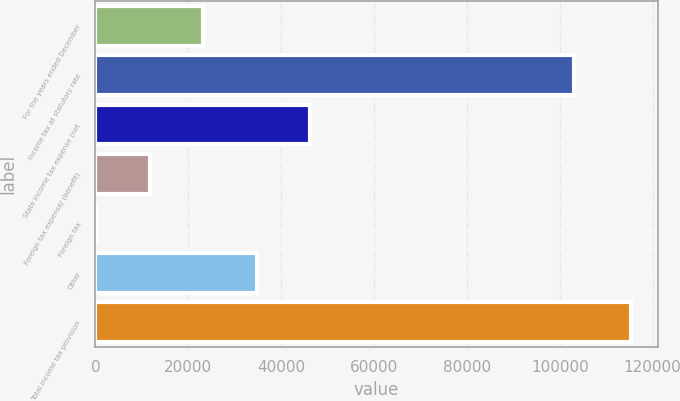Convert chart. <chart><loc_0><loc_0><loc_500><loc_500><bar_chart><fcel>For the years ended December<fcel>Income tax at statutory rate<fcel>State income tax expense (net<fcel>Foreign tax expense/ (benefit)<fcel>Foreign tax<fcel>Other<fcel>Total income tax provision<nl><fcel>23252.4<fcel>103075<fcel>46283.8<fcel>11736.7<fcel>221<fcel>34768.1<fcel>115378<nl></chart> 